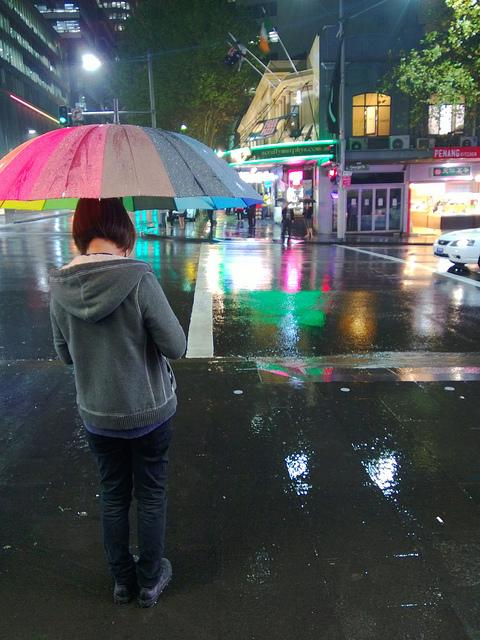What does the person standing here wait to see?

Choices:
A) walk light
B) candle
C) their friend
D) warning walk light 